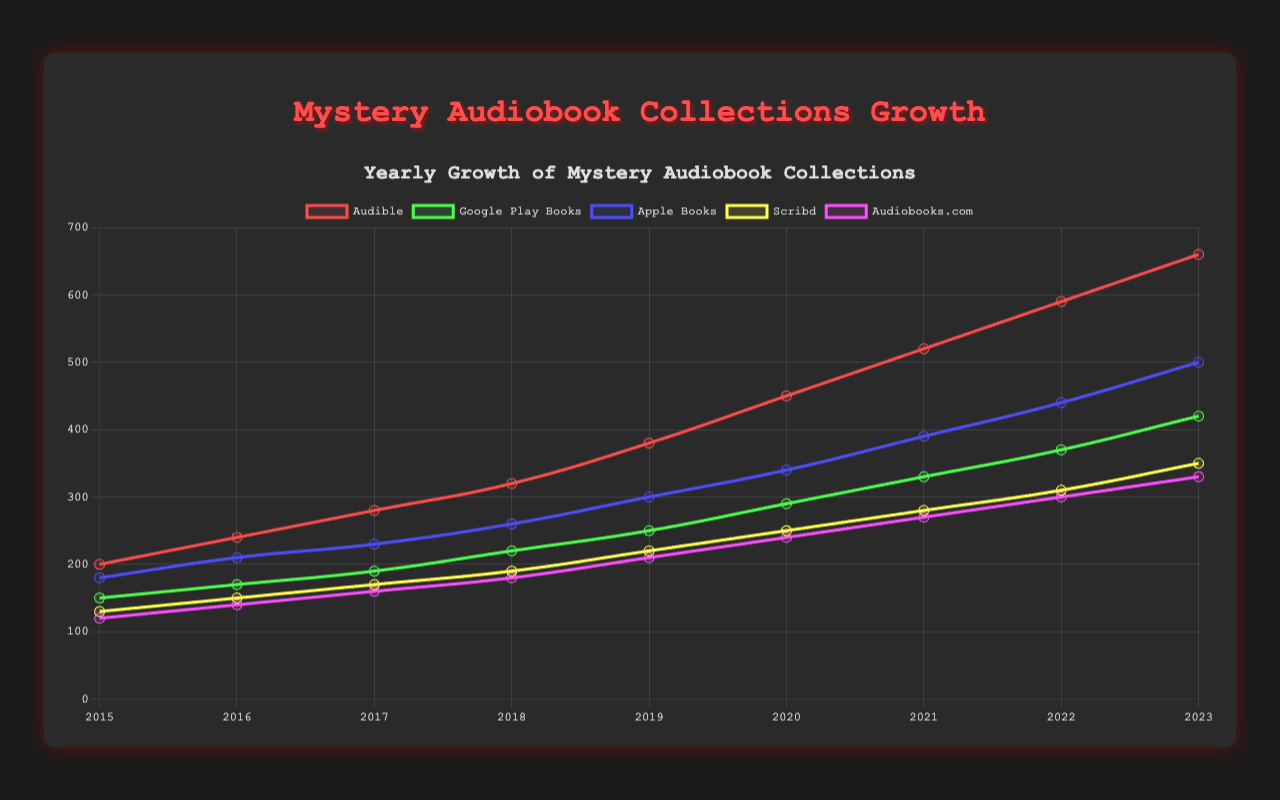Which platform showed the highest growth in mystery audiobook collections by 2023? To determine this, we look at the line chart for the year 2023 and compare the values for each platform. Audible has the highest value in 2023 with 660.
Answer: Audible By how much did Google Play Books' mystery audiobook collection increase from 2015 to 2023? To find the increase, subtract the 2015 value from the 2023 value for Google Play Books. The values are 420 in 2023 and 150 in 2015. The increase is 420 - 150.
Answer: 270 Which year saw the highest increase in the number of mystery audiobooks for Audible compared to the previous year? First, calculate the yearly differences for Audible: 2016-2015: 40, 2017-2016: 40, 2018-2017: 40, 2019-2018: 60, 2020-2019: 70, 2021-2020: 70, 2022-2021: 70, 2023-2022: 70. The highest increase is 70, observed in the years 2020, 2021, 2022, and 2023.
Answer: 2020, 2021, 2022, and 2023 On average, how many new mystery audiobooks per year did Apple Books add from 2015 to 2023? First, find the total increase for Apple Books by subtracting 2015's value from 2023's value: 500 - 180 = 320. Then, divide this by the number of years (2023-2015=8).
Answer: 40 Compare the yearly growth trends for Scribd and Audiobooks.com. Who had a steeper yearly increase, on average? Calculate the average yearly increase for both platforms: 
Scribd: (350-130)/8 = 27.5 per year 
Audiobooks.com: (330-120)/8 = 26.25 per year 
Scribd has a slightly steeper increase.
Answer: Scribd Which year did Audible first surpass 500 mystery audiobooks in its collection? Find the first year when Audible's value is above 500. The chart shows that in 2021, Audible has 520 audiobooks.
Answer: 2021 What was the combined total number of mystery audiobooks across all platforms in 2019? Add up the values for all platforms in 2019: 380 (Audible) + 250 (Google Play Books) + 300 (Apple Books) + 220 (Scribd) + 210 (Audiobooks.com) = 1360.
Answer: 1360 Which year did Google Play Books' collection surpass 300 for the first time? Look at the values for Google Play Books each year and find the first year it exceeds 300. In 2020, its collection reached 290, and in 2021, it reached 330, so 2021 is the first year it surpassed 300.
Answer: 2021 Comparing 2018 and 2022, which platform had the largest absolute increase in mystery audiobooks? Calculate the increase for each platform between 2018 and 2022:
Audible: 590 - 320 = 270
Google Play Books: 370 - 220 = 150
Apple Books: 440 - 260 = 180
Scribd: 310 - 190 = 120
Audiobooks.com: 300 - 180 = 120
Audible had the largest increase.
Answer: Audible 